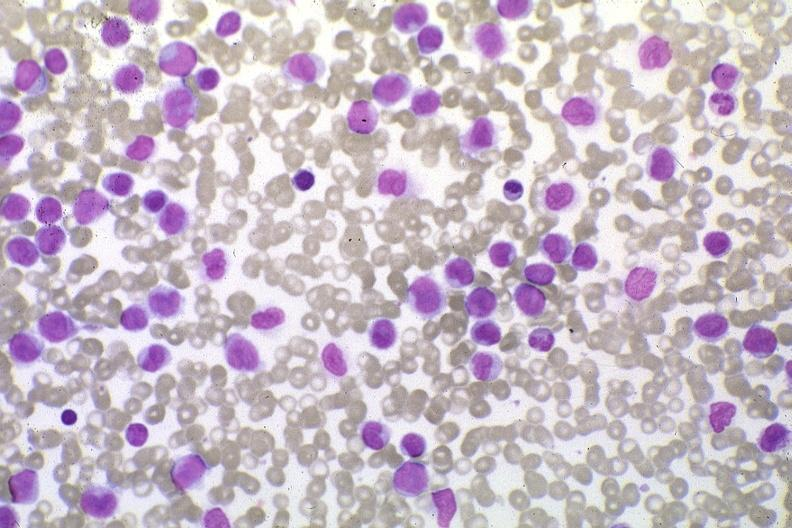s history present?
Answer the question using a single word or phrase. No 